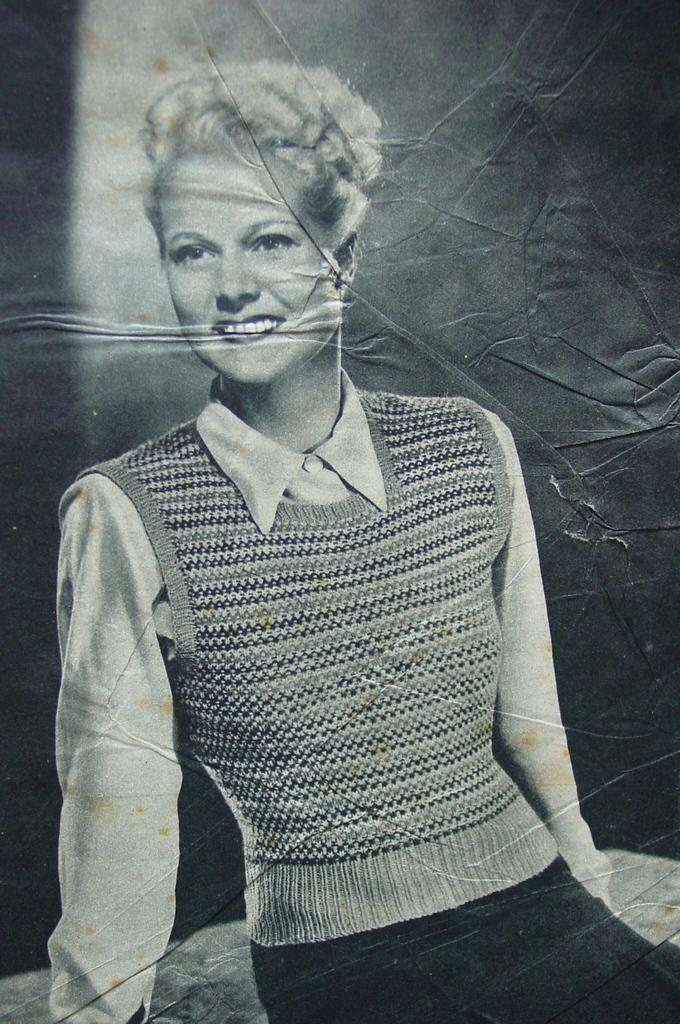What is present in the picture? There is a poster in the picture. What is depicted on the poster? The poster features a woman sitting. What color is the hen's blood in the image? There is no hen or blood present in the image; it only features a poster with a woman sitting. 